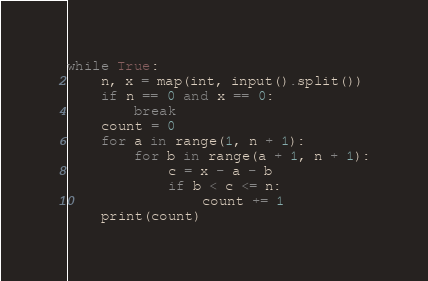Convert code to text. <code><loc_0><loc_0><loc_500><loc_500><_Python_>while True:
    n, x = map(int, input().split())
    if n == 0 and x == 0:
        break
    count = 0
    for a in range(1, n + 1):
        for b in range(a + 1, n + 1):
            c = x - a - b
            if b < c <= n:
                count += 1
    print(count)

</code> 